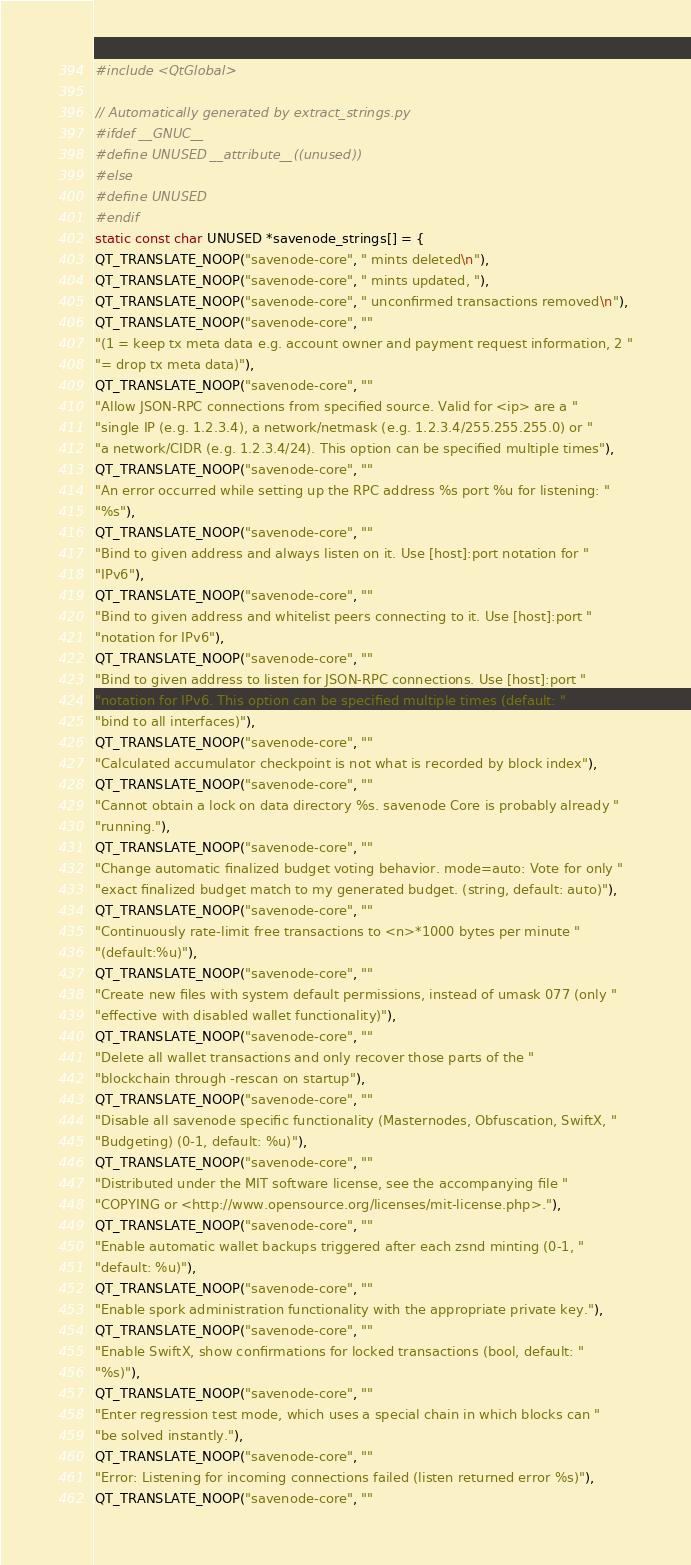<code> <loc_0><loc_0><loc_500><loc_500><_C++_>

#include <QtGlobal>

// Automatically generated by extract_strings.py
#ifdef __GNUC__
#define UNUSED __attribute__((unused))
#else
#define UNUSED
#endif
static const char UNUSED *savenode_strings[] = {
QT_TRANSLATE_NOOP("savenode-core", " mints deleted\n"),
QT_TRANSLATE_NOOP("savenode-core", " mints updated, "),
QT_TRANSLATE_NOOP("savenode-core", " unconfirmed transactions removed\n"),
QT_TRANSLATE_NOOP("savenode-core", ""
"(1 = keep tx meta data e.g. account owner and payment request information, 2 "
"= drop tx meta data)"),
QT_TRANSLATE_NOOP("savenode-core", ""
"Allow JSON-RPC connections from specified source. Valid for <ip> are a "
"single IP (e.g. 1.2.3.4), a network/netmask (e.g. 1.2.3.4/255.255.255.0) or "
"a network/CIDR (e.g. 1.2.3.4/24). This option can be specified multiple times"),
QT_TRANSLATE_NOOP("savenode-core", ""
"An error occurred while setting up the RPC address %s port %u for listening: "
"%s"),
QT_TRANSLATE_NOOP("savenode-core", ""
"Bind to given address and always listen on it. Use [host]:port notation for "
"IPv6"),
QT_TRANSLATE_NOOP("savenode-core", ""
"Bind to given address and whitelist peers connecting to it. Use [host]:port "
"notation for IPv6"),
QT_TRANSLATE_NOOP("savenode-core", ""
"Bind to given address to listen for JSON-RPC connections. Use [host]:port "
"notation for IPv6. This option can be specified multiple times (default: "
"bind to all interfaces)"),
QT_TRANSLATE_NOOP("savenode-core", ""
"Calculated accumulator checkpoint is not what is recorded by block index"),
QT_TRANSLATE_NOOP("savenode-core", ""
"Cannot obtain a lock on data directory %s. savenode Core is probably already "
"running."),
QT_TRANSLATE_NOOP("savenode-core", ""
"Change automatic finalized budget voting behavior. mode=auto: Vote for only "
"exact finalized budget match to my generated budget. (string, default: auto)"),
QT_TRANSLATE_NOOP("savenode-core", ""
"Continuously rate-limit free transactions to <n>*1000 bytes per minute "
"(default:%u)"),
QT_TRANSLATE_NOOP("savenode-core", ""
"Create new files with system default permissions, instead of umask 077 (only "
"effective with disabled wallet functionality)"),
QT_TRANSLATE_NOOP("savenode-core", ""
"Delete all wallet transactions and only recover those parts of the "
"blockchain through -rescan on startup"),
QT_TRANSLATE_NOOP("savenode-core", ""
"Disable all savenode specific functionality (Masternodes, Obfuscation, SwiftX, "
"Budgeting) (0-1, default: %u)"),
QT_TRANSLATE_NOOP("savenode-core", ""
"Distributed under the MIT software license, see the accompanying file "
"COPYING or <http://www.opensource.org/licenses/mit-license.php>."),
QT_TRANSLATE_NOOP("savenode-core", ""
"Enable automatic wallet backups triggered after each zsnd minting (0-1, "
"default: %u)"),
QT_TRANSLATE_NOOP("savenode-core", ""
"Enable spork administration functionality with the appropriate private key."),
QT_TRANSLATE_NOOP("savenode-core", ""
"Enable SwiftX, show confirmations for locked transactions (bool, default: "
"%s)"),
QT_TRANSLATE_NOOP("savenode-core", ""
"Enter regression test mode, which uses a special chain in which blocks can "
"be solved instantly."),
QT_TRANSLATE_NOOP("savenode-core", ""
"Error: Listening for incoming connections failed (listen returned error %s)"),
QT_TRANSLATE_NOOP("savenode-core", ""</code> 